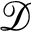Convert formula to latex. <formula><loc_0><loc_0><loc_500><loc_500>\mathcal { D }</formula> 